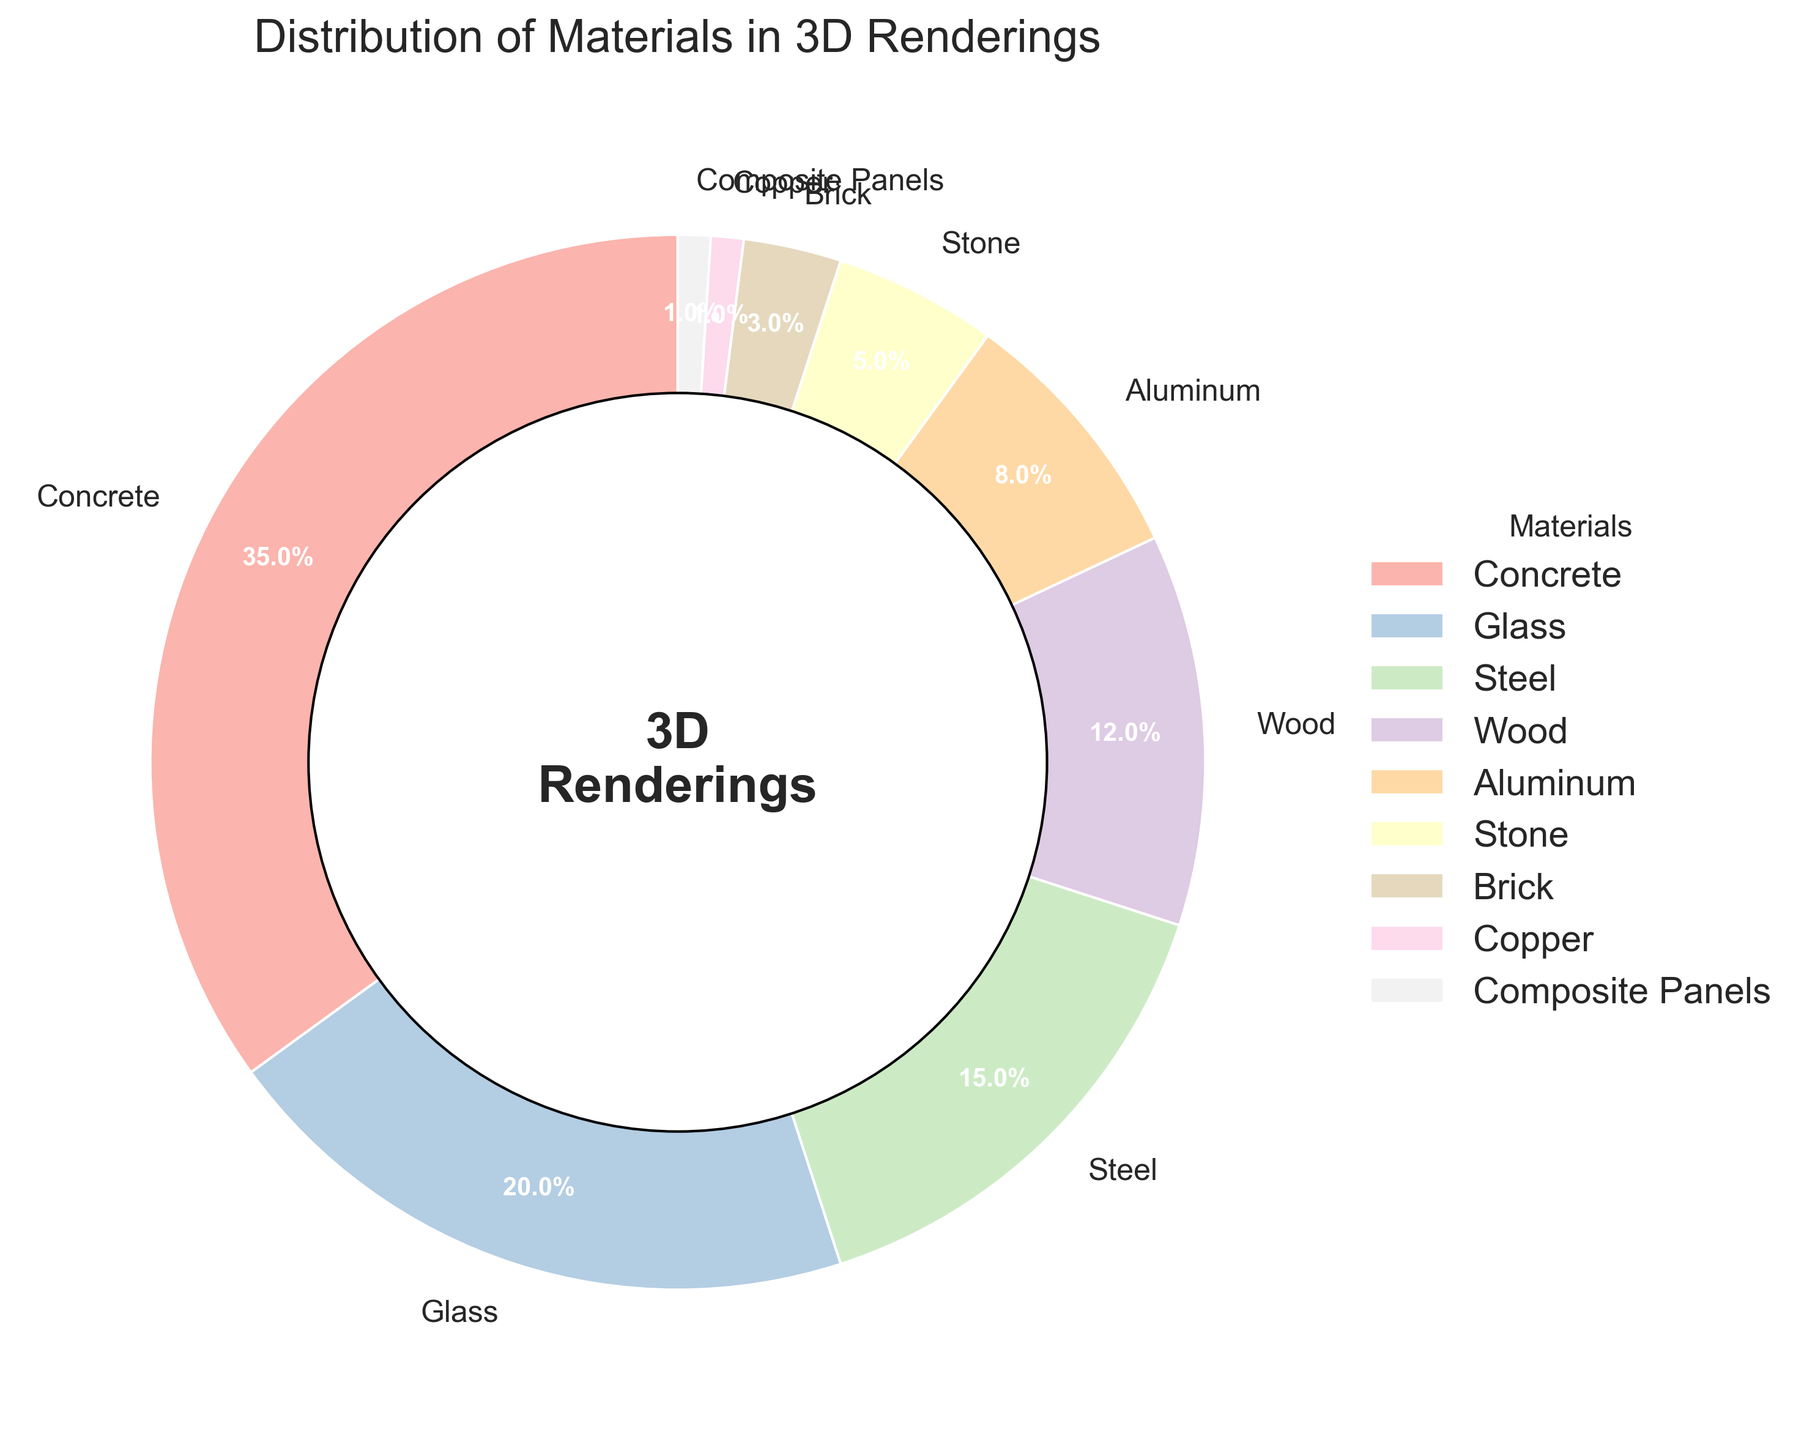What's the material with the highest percentage? Look at the pie chart segments and find the one that represents the largest percentage. The label for this segment will be "Concrete" with 35%.
Answer: Concrete What is the combined percentage of Concrete and Glass used in 3D renderings? Sum the percentages for Concrete (35%) and Glass (20%). So, 35 + 20 = 55%.
Answer: 55% How much more percentage does Concrete have compared to Steel? Subtract the percentage of Steel (15%) from the percentage of Concrete (35%). So, 35 - 15 = 20%.
Answer: 20% Which two materials combined have the same percentage as Wood? Look for materials whose percentages add up to the percentage of Wood (12%). Aluminum (8%) and Stone (5%) together sum to 8 + 5 = 13%, but Brick (3%) and Aluminum (8%) sum to 3 + 8 = 11%, which is closer to 12%. Considering these, Copper (1%) and Composite Panels (1%) sum to 1 + 1 = 2%, which does not match as well. Adjustments to find accurate closer pair must be done.
Answer: Aluminum and Stone What is the sum of the percentages for Aluminum, Stone, Brick, Copper, and Composite Panels? Add up the percentages of Aluminum (8%), Stone (5%), Brick (3%), Copper (1%), and Composite Panels (1%). So, 8 + 5 + 3 + 1 + 1 = 18%.
Answer: 18% Which material has the smallest percentage, and what is it? Identify the segment with the smallest slice in the pie chart, labeled Copper and Composite Panels each having 1%. Both materials have the smallest slices at equal percentages.
Answer: Copper and Composite Panels, 1% How many materials have a percentage higher than 10%? Count the sections (Concrete, Glass, Steel, and Wood) that have percentages higher than 10%, totaling 4 segments in the pie chart.
Answer: 4 Which material is shown in blue, and what percentage does it represent? Reference the segment shown in blue and find it labeled as Glass, which represents 20%.
Answer: Glass, 20% 